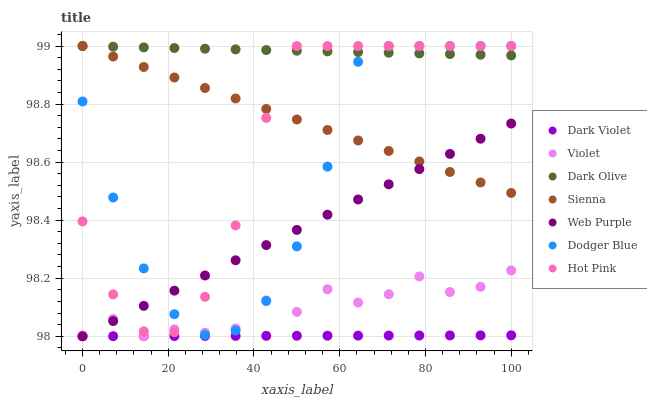Does Dark Violet have the minimum area under the curve?
Answer yes or no. Yes. Does Dark Olive have the maximum area under the curve?
Answer yes or no. Yes. Does Dark Olive have the minimum area under the curve?
Answer yes or no. No. Does Dark Violet have the maximum area under the curve?
Answer yes or no. No. Is Dark Olive the smoothest?
Answer yes or no. Yes. Is Violet the roughest?
Answer yes or no. Yes. Is Dark Violet the smoothest?
Answer yes or no. No. Is Dark Violet the roughest?
Answer yes or no. No. Does Dark Violet have the lowest value?
Answer yes or no. Yes. Does Dark Olive have the lowest value?
Answer yes or no. No. Does Dodger Blue have the highest value?
Answer yes or no. Yes. Does Dark Violet have the highest value?
Answer yes or no. No. Is Dark Violet less than Sienna?
Answer yes or no. Yes. Is Dark Olive greater than Web Purple?
Answer yes or no. Yes. Does Web Purple intersect Sienna?
Answer yes or no. Yes. Is Web Purple less than Sienna?
Answer yes or no. No. Is Web Purple greater than Sienna?
Answer yes or no. No. Does Dark Violet intersect Sienna?
Answer yes or no. No. 